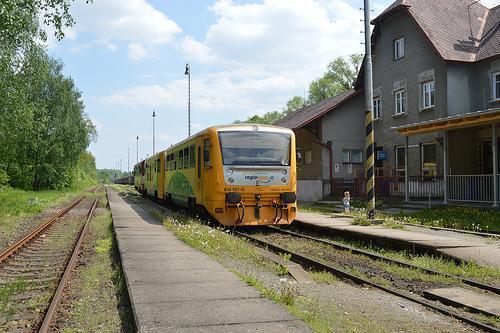How many trains are there?
Give a very brief answer. 1. 